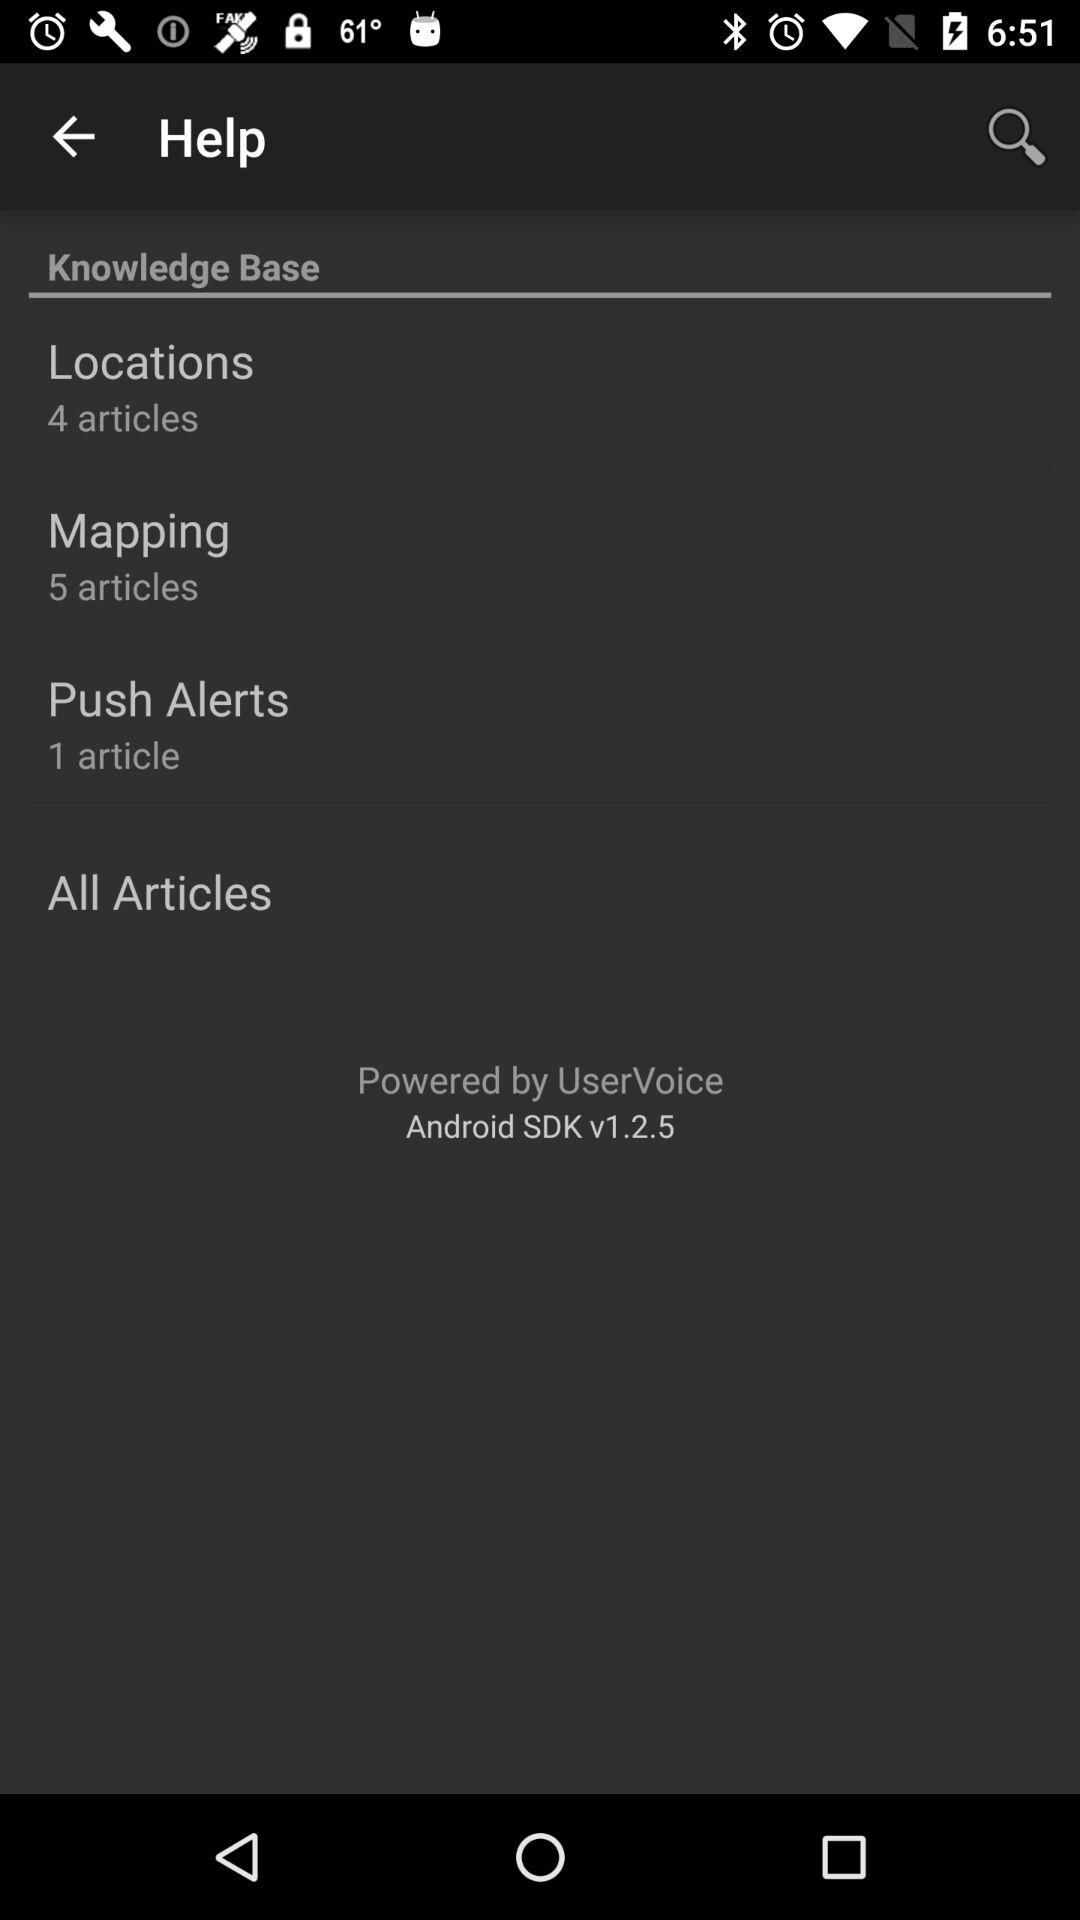What is the number of articles in "Mapping"? The number of articles is 5. 